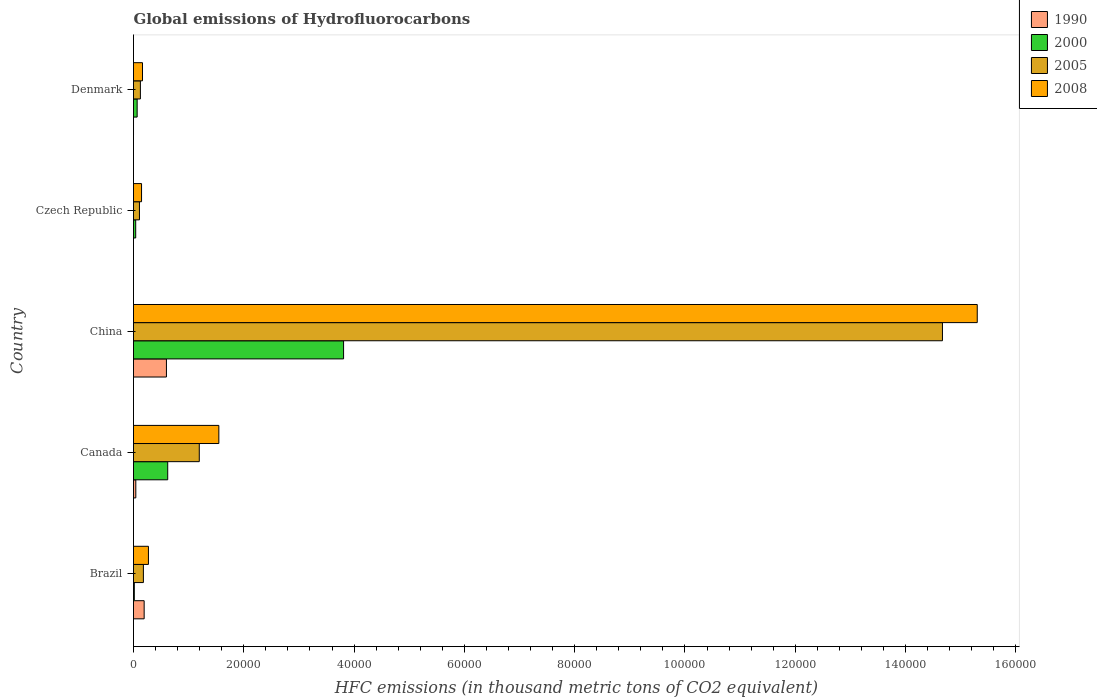How many groups of bars are there?
Provide a short and direct response. 5. How many bars are there on the 2nd tick from the top?
Provide a short and direct response. 4. In how many cases, is the number of bars for a given country not equal to the number of legend labels?
Keep it short and to the point. 0. What is the global emissions of Hydrofluorocarbons in 1990 in Canada?
Your response must be concise. 418.5. Across all countries, what is the maximum global emissions of Hydrofluorocarbons in 1990?
Your answer should be compact. 5970.1. Across all countries, what is the minimum global emissions of Hydrofluorocarbons in 2008?
Your response must be concise. 1459. In which country was the global emissions of Hydrofluorocarbons in 2008 maximum?
Provide a succinct answer. China. In which country was the global emissions of Hydrofluorocarbons in 2005 minimum?
Your answer should be compact. Czech Republic. What is the total global emissions of Hydrofluorocarbons in 2000 in the graph?
Ensure brevity in your answer.  4.55e+04. What is the difference between the global emissions of Hydrofluorocarbons in 2008 in Brazil and that in Denmark?
Ensure brevity in your answer.  1077.9. What is the difference between the global emissions of Hydrofluorocarbons in 1990 in Denmark and the global emissions of Hydrofluorocarbons in 2005 in Canada?
Provide a succinct answer. -1.19e+04. What is the average global emissions of Hydrofluorocarbons in 2008 per country?
Offer a very short reply. 3.49e+04. What is the difference between the global emissions of Hydrofluorocarbons in 2000 and global emissions of Hydrofluorocarbons in 2005 in Czech Republic?
Provide a short and direct response. -679.2. What is the ratio of the global emissions of Hydrofluorocarbons in 1990 in China to that in Denmark?
Ensure brevity in your answer.  1.99e+04. Is the difference between the global emissions of Hydrofluorocarbons in 2000 in Canada and China greater than the difference between the global emissions of Hydrofluorocarbons in 2005 in Canada and China?
Ensure brevity in your answer.  Yes. What is the difference between the highest and the second highest global emissions of Hydrofluorocarbons in 1990?
Give a very brief answer. 4039.4. What is the difference between the highest and the lowest global emissions of Hydrofluorocarbons in 2000?
Keep it short and to the point. 3.79e+04. Is the sum of the global emissions of Hydrofluorocarbons in 2005 in Brazil and Denmark greater than the maximum global emissions of Hydrofluorocarbons in 1990 across all countries?
Give a very brief answer. No. Is it the case that in every country, the sum of the global emissions of Hydrofluorocarbons in 2000 and global emissions of Hydrofluorocarbons in 2005 is greater than the sum of global emissions of Hydrofluorocarbons in 1990 and global emissions of Hydrofluorocarbons in 2008?
Offer a very short reply. No. What does the 2nd bar from the top in China represents?
Make the answer very short. 2005. What does the 2nd bar from the bottom in China represents?
Offer a terse response. 2000. Is it the case that in every country, the sum of the global emissions of Hydrofluorocarbons in 2008 and global emissions of Hydrofluorocarbons in 1990 is greater than the global emissions of Hydrofluorocarbons in 2005?
Your answer should be compact. Yes. Are all the bars in the graph horizontal?
Your answer should be compact. Yes. How many countries are there in the graph?
Offer a terse response. 5. What is the difference between two consecutive major ticks on the X-axis?
Your answer should be very brief. 2.00e+04. Does the graph contain any zero values?
Ensure brevity in your answer.  No. How are the legend labels stacked?
Your answer should be very brief. Vertical. What is the title of the graph?
Offer a terse response. Global emissions of Hydrofluorocarbons. What is the label or title of the X-axis?
Provide a short and direct response. HFC emissions (in thousand metric tons of CO2 equivalent). What is the HFC emissions (in thousand metric tons of CO2 equivalent) in 1990 in Brazil?
Keep it short and to the point. 1930.7. What is the HFC emissions (in thousand metric tons of CO2 equivalent) in 2000 in Brazil?
Your answer should be very brief. 147.4. What is the HFC emissions (in thousand metric tons of CO2 equivalent) of 2005 in Brazil?
Your response must be concise. 1793.4. What is the HFC emissions (in thousand metric tons of CO2 equivalent) of 2008 in Brazil?
Your answer should be compact. 2707.5. What is the HFC emissions (in thousand metric tons of CO2 equivalent) of 1990 in Canada?
Keep it short and to the point. 418.5. What is the HFC emissions (in thousand metric tons of CO2 equivalent) in 2000 in Canada?
Ensure brevity in your answer.  6202.8. What is the HFC emissions (in thousand metric tons of CO2 equivalent) in 2005 in Canada?
Make the answer very short. 1.19e+04. What is the HFC emissions (in thousand metric tons of CO2 equivalent) in 2008 in Canada?
Your answer should be very brief. 1.55e+04. What is the HFC emissions (in thousand metric tons of CO2 equivalent) in 1990 in China?
Provide a short and direct response. 5970.1. What is the HFC emissions (in thousand metric tons of CO2 equivalent) in 2000 in China?
Keep it short and to the point. 3.81e+04. What is the HFC emissions (in thousand metric tons of CO2 equivalent) of 2005 in China?
Offer a terse response. 1.47e+05. What is the HFC emissions (in thousand metric tons of CO2 equivalent) in 2008 in China?
Your response must be concise. 1.53e+05. What is the HFC emissions (in thousand metric tons of CO2 equivalent) in 2000 in Czech Republic?
Your answer should be very brief. 399.5. What is the HFC emissions (in thousand metric tons of CO2 equivalent) in 2005 in Czech Republic?
Provide a succinct answer. 1078.7. What is the HFC emissions (in thousand metric tons of CO2 equivalent) of 2008 in Czech Republic?
Provide a succinct answer. 1459. What is the HFC emissions (in thousand metric tons of CO2 equivalent) of 1990 in Denmark?
Offer a terse response. 0.3. What is the HFC emissions (in thousand metric tons of CO2 equivalent) of 2000 in Denmark?
Offer a very short reply. 662.2. What is the HFC emissions (in thousand metric tons of CO2 equivalent) of 2005 in Denmark?
Provide a succinct answer. 1249.5. What is the HFC emissions (in thousand metric tons of CO2 equivalent) of 2008 in Denmark?
Offer a very short reply. 1629.6. Across all countries, what is the maximum HFC emissions (in thousand metric tons of CO2 equivalent) in 1990?
Ensure brevity in your answer.  5970.1. Across all countries, what is the maximum HFC emissions (in thousand metric tons of CO2 equivalent) in 2000?
Your answer should be very brief. 3.81e+04. Across all countries, what is the maximum HFC emissions (in thousand metric tons of CO2 equivalent) in 2005?
Your answer should be very brief. 1.47e+05. Across all countries, what is the maximum HFC emissions (in thousand metric tons of CO2 equivalent) in 2008?
Give a very brief answer. 1.53e+05. Across all countries, what is the minimum HFC emissions (in thousand metric tons of CO2 equivalent) in 1990?
Make the answer very short. 0.1. Across all countries, what is the minimum HFC emissions (in thousand metric tons of CO2 equivalent) of 2000?
Give a very brief answer. 147.4. Across all countries, what is the minimum HFC emissions (in thousand metric tons of CO2 equivalent) in 2005?
Ensure brevity in your answer.  1078.7. Across all countries, what is the minimum HFC emissions (in thousand metric tons of CO2 equivalent) in 2008?
Give a very brief answer. 1459. What is the total HFC emissions (in thousand metric tons of CO2 equivalent) in 1990 in the graph?
Your response must be concise. 8319.7. What is the total HFC emissions (in thousand metric tons of CO2 equivalent) of 2000 in the graph?
Make the answer very short. 4.55e+04. What is the total HFC emissions (in thousand metric tons of CO2 equivalent) of 2005 in the graph?
Provide a short and direct response. 1.63e+05. What is the total HFC emissions (in thousand metric tons of CO2 equivalent) of 2008 in the graph?
Your answer should be compact. 1.74e+05. What is the difference between the HFC emissions (in thousand metric tons of CO2 equivalent) in 1990 in Brazil and that in Canada?
Your answer should be very brief. 1512.2. What is the difference between the HFC emissions (in thousand metric tons of CO2 equivalent) of 2000 in Brazil and that in Canada?
Make the answer very short. -6055.4. What is the difference between the HFC emissions (in thousand metric tons of CO2 equivalent) of 2005 in Brazil and that in Canada?
Give a very brief answer. -1.01e+04. What is the difference between the HFC emissions (in thousand metric tons of CO2 equivalent) in 2008 in Brazil and that in Canada?
Provide a short and direct response. -1.28e+04. What is the difference between the HFC emissions (in thousand metric tons of CO2 equivalent) of 1990 in Brazil and that in China?
Make the answer very short. -4039.4. What is the difference between the HFC emissions (in thousand metric tons of CO2 equivalent) of 2000 in Brazil and that in China?
Provide a short and direct response. -3.79e+04. What is the difference between the HFC emissions (in thousand metric tons of CO2 equivalent) of 2005 in Brazil and that in China?
Your response must be concise. -1.45e+05. What is the difference between the HFC emissions (in thousand metric tons of CO2 equivalent) in 2008 in Brazil and that in China?
Provide a short and direct response. -1.50e+05. What is the difference between the HFC emissions (in thousand metric tons of CO2 equivalent) in 1990 in Brazil and that in Czech Republic?
Provide a succinct answer. 1930.6. What is the difference between the HFC emissions (in thousand metric tons of CO2 equivalent) of 2000 in Brazil and that in Czech Republic?
Keep it short and to the point. -252.1. What is the difference between the HFC emissions (in thousand metric tons of CO2 equivalent) in 2005 in Brazil and that in Czech Republic?
Offer a terse response. 714.7. What is the difference between the HFC emissions (in thousand metric tons of CO2 equivalent) of 2008 in Brazil and that in Czech Republic?
Your answer should be very brief. 1248.5. What is the difference between the HFC emissions (in thousand metric tons of CO2 equivalent) of 1990 in Brazil and that in Denmark?
Make the answer very short. 1930.4. What is the difference between the HFC emissions (in thousand metric tons of CO2 equivalent) of 2000 in Brazil and that in Denmark?
Offer a very short reply. -514.8. What is the difference between the HFC emissions (in thousand metric tons of CO2 equivalent) in 2005 in Brazil and that in Denmark?
Give a very brief answer. 543.9. What is the difference between the HFC emissions (in thousand metric tons of CO2 equivalent) in 2008 in Brazil and that in Denmark?
Ensure brevity in your answer.  1077.9. What is the difference between the HFC emissions (in thousand metric tons of CO2 equivalent) in 1990 in Canada and that in China?
Your answer should be compact. -5551.6. What is the difference between the HFC emissions (in thousand metric tons of CO2 equivalent) in 2000 in Canada and that in China?
Your answer should be compact. -3.19e+04. What is the difference between the HFC emissions (in thousand metric tons of CO2 equivalent) in 2005 in Canada and that in China?
Keep it short and to the point. -1.35e+05. What is the difference between the HFC emissions (in thousand metric tons of CO2 equivalent) in 2008 in Canada and that in China?
Make the answer very short. -1.38e+05. What is the difference between the HFC emissions (in thousand metric tons of CO2 equivalent) in 1990 in Canada and that in Czech Republic?
Make the answer very short. 418.4. What is the difference between the HFC emissions (in thousand metric tons of CO2 equivalent) in 2000 in Canada and that in Czech Republic?
Your answer should be compact. 5803.3. What is the difference between the HFC emissions (in thousand metric tons of CO2 equivalent) in 2005 in Canada and that in Czech Republic?
Provide a short and direct response. 1.08e+04. What is the difference between the HFC emissions (in thousand metric tons of CO2 equivalent) in 2008 in Canada and that in Czech Republic?
Offer a very short reply. 1.40e+04. What is the difference between the HFC emissions (in thousand metric tons of CO2 equivalent) in 1990 in Canada and that in Denmark?
Provide a short and direct response. 418.2. What is the difference between the HFC emissions (in thousand metric tons of CO2 equivalent) in 2000 in Canada and that in Denmark?
Offer a very short reply. 5540.6. What is the difference between the HFC emissions (in thousand metric tons of CO2 equivalent) in 2005 in Canada and that in Denmark?
Ensure brevity in your answer.  1.07e+04. What is the difference between the HFC emissions (in thousand metric tons of CO2 equivalent) in 2008 in Canada and that in Denmark?
Give a very brief answer. 1.38e+04. What is the difference between the HFC emissions (in thousand metric tons of CO2 equivalent) of 1990 in China and that in Czech Republic?
Your response must be concise. 5970. What is the difference between the HFC emissions (in thousand metric tons of CO2 equivalent) of 2000 in China and that in Czech Republic?
Provide a succinct answer. 3.77e+04. What is the difference between the HFC emissions (in thousand metric tons of CO2 equivalent) in 2005 in China and that in Czech Republic?
Your answer should be very brief. 1.46e+05. What is the difference between the HFC emissions (in thousand metric tons of CO2 equivalent) of 2008 in China and that in Czech Republic?
Give a very brief answer. 1.52e+05. What is the difference between the HFC emissions (in thousand metric tons of CO2 equivalent) of 1990 in China and that in Denmark?
Ensure brevity in your answer.  5969.8. What is the difference between the HFC emissions (in thousand metric tons of CO2 equivalent) of 2000 in China and that in Denmark?
Ensure brevity in your answer.  3.74e+04. What is the difference between the HFC emissions (in thousand metric tons of CO2 equivalent) of 2005 in China and that in Denmark?
Offer a very short reply. 1.45e+05. What is the difference between the HFC emissions (in thousand metric tons of CO2 equivalent) of 2008 in China and that in Denmark?
Offer a very short reply. 1.51e+05. What is the difference between the HFC emissions (in thousand metric tons of CO2 equivalent) in 2000 in Czech Republic and that in Denmark?
Your answer should be compact. -262.7. What is the difference between the HFC emissions (in thousand metric tons of CO2 equivalent) of 2005 in Czech Republic and that in Denmark?
Provide a short and direct response. -170.8. What is the difference between the HFC emissions (in thousand metric tons of CO2 equivalent) of 2008 in Czech Republic and that in Denmark?
Give a very brief answer. -170.6. What is the difference between the HFC emissions (in thousand metric tons of CO2 equivalent) in 1990 in Brazil and the HFC emissions (in thousand metric tons of CO2 equivalent) in 2000 in Canada?
Your answer should be compact. -4272.1. What is the difference between the HFC emissions (in thousand metric tons of CO2 equivalent) in 1990 in Brazil and the HFC emissions (in thousand metric tons of CO2 equivalent) in 2005 in Canada?
Provide a succinct answer. -9997.7. What is the difference between the HFC emissions (in thousand metric tons of CO2 equivalent) in 1990 in Brazil and the HFC emissions (in thousand metric tons of CO2 equivalent) in 2008 in Canada?
Give a very brief answer. -1.35e+04. What is the difference between the HFC emissions (in thousand metric tons of CO2 equivalent) of 2000 in Brazil and the HFC emissions (in thousand metric tons of CO2 equivalent) of 2005 in Canada?
Provide a succinct answer. -1.18e+04. What is the difference between the HFC emissions (in thousand metric tons of CO2 equivalent) of 2000 in Brazil and the HFC emissions (in thousand metric tons of CO2 equivalent) of 2008 in Canada?
Make the answer very short. -1.53e+04. What is the difference between the HFC emissions (in thousand metric tons of CO2 equivalent) in 2005 in Brazil and the HFC emissions (in thousand metric tons of CO2 equivalent) in 2008 in Canada?
Your response must be concise. -1.37e+04. What is the difference between the HFC emissions (in thousand metric tons of CO2 equivalent) of 1990 in Brazil and the HFC emissions (in thousand metric tons of CO2 equivalent) of 2000 in China?
Ensure brevity in your answer.  -3.62e+04. What is the difference between the HFC emissions (in thousand metric tons of CO2 equivalent) of 1990 in Brazil and the HFC emissions (in thousand metric tons of CO2 equivalent) of 2005 in China?
Provide a short and direct response. -1.45e+05. What is the difference between the HFC emissions (in thousand metric tons of CO2 equivalent) in 1990 in Brazil and the HFC emissions (in thousand metric tons of CO2 equivalent) in 2008 in China?
Offer a very short reply. -1.51e+05. What is the difference between the HFC emissions (in thousand metric tons of CO2 equivalent) of 2000 in Brazil and the HFC emissions (in thousand metric tons of CO2 equivalent) of 2005 in China?
Ensure brevity in your answer.  -1.47e+05. What is the difference between the HFC emissions (in thousand metric tons of CO2 equivalent) in 2000 in Brazil and the HFC emissions (in thousand metric tons of CO2 equivalent) in 2008 in China?
Keep it short and to the point. -1.53e+05. What is the difference between the HFC emissions (in thousand metric tons of CO2 equivalent) of 2005 in Brazil and the HFC emissions (in thousand metric tons of CO2 equivalent) of 2008 in China?
Offer a terse response. -1.51e+05. What is the difference between the HFC emissions (in thousand metric tons of CO2 equivalent) in 1990 in Brazil and the HFC emissions (in thousand metric tons of CO2 equivalent) in 2000 in Czech Republic?
Provide a short and direct response. 1531.2. What is the difference between the HFC emissions (in thousand metric tons of CO2 equivalent) in 1990 in Brazil and the HFC emissions (in thousand metric tons of CO2 equivalent) in 2005 in Czech Republic?
Your answer should be very brief. 852. What is the difference between the HFC emissions (in thousand metric tons of CO2 equivalent) of 1990 in Brazil and the HFC emissions (in thousand metric tons of CO2 equivalent) of 2008 in Czech Republic?
Your response must be concise. 471.7. What is the difference between the HFC emissions (in thousand metric tons of CO2 equivalent) in 2000 in Brazil and the HFC emissions (in thousand metric tons of CO2 equivalent) in 2005 in Czech Republic?
Your response must be concise. -931.3. What is the difference between the HFC emissions (in thousand metric tons of CO2 equivalent) of 2000 in Brazil and the HFC emissions (in thousand metric tons of CO2 equivalent) of 2008 in Czech Republic?
Offer a terse response. -1311.6. What is the difference between the HFC emissions (in thousand metric tons of CO2 equivalent) in 2005 in Brazil and the HFC emissions (in thousand metric tons of CO2 equivalent) in 2008 in Czech Republic?
Ensure brevity in your answer.  334.4. What is the difference between the HFC emissions (in thousand metric tons of CO2 equivalent) in 1990 in Brazil and the HFC emissions (in thousand metric tons of CO2 equivalent) in 2000 in Denmark?
Provide a succinct answer. 1268.5. What is the difference between the HFC emissions (in thousand metric tons of CO2 equivalent) of 1990 in Brazil and the HFC emissions (in thousand metric tons of CO2 equivalent) of 2005 in Denmark?
Your answer should be very brief. 681.2. What is the difference between the HFC emissions (in thousand metric tons of CO2 equivalent) of 1990 in Brazil and the HFC emissions (in thousand metric tons of CO2 equivalent) of 2008 in Denmark?
Your answer should be very brief. 301.1. What is the difference between the HFC emissions (in thousand metric tons of CO2 equivalent) in 2000 in Brazil and the HFC emissions (in thousand metric tons of CO2 equivalent) in 2005 in Denmark?
Your response must be concise. -1102.1. What is the difference between the HFC emissions (in thousand metric tons of CO2 equivalent) in 2000 in Brazil and the HFC emissions (in thousand metric tons of CO2 equivalent) in 2008 in Denmark?
Offer a terse response. -1482.2. What is the difference between the HFC emissions (in thousand metric tons of CO2 equivalent) in 2005 in Brazil and the HFC emissions (in thousand metric tons of CO2 equivalent) in 2008 in Denmark?
Provide a succinct answer. 163.8. What is the difference between the HFC emissions (in thousand metric tons of CO2 equivalent) of 1990 in Canada and the HFC emissions (in thousand metric tons of CO2 equivalent) of 2000 in China?
Give a very brief answer. -3.77e+04. What is the difference between the HFC emissions (in thousand metric tons of CO2 equivalent) of 1990 in Canada and the HFC emissions (in thousand metric tons of CO2 equivalent) of 2005 in China?
Offer a very short reply. -1.46e+05. What is the difference between the HFC emissions (in thousand metric tons of CO2 equivalent) in 1990 in Canada and the HFC emissions (in thousand metric tons of CO2 equivalent) in 2008 in China?
Provide a succinct answer. -1.53e+05. What is the difference between the HFC emissions (in thousand metric tons of CO2 equivalent) in 2000 in Canada and the HFC emissions (in thousand metric tons of CO2 equivalent) in 2005 in China?
Offer a very short reply. -1.40e+05. What is the difference between the HFC emissions (in thousand metric tons of CO2 equivalent) in 2000 in Canada and the HFC emissions (in thousand metric tons of CO2 equivalent) in 2008 in China?
Your answer should be compact. -1.47e+05. What is the difference between the HFC emissions (in thousand metric tons of CO2 equivalent) of 2005 in Canada and the HFC emissions (in thousand metric tons of CO2 equivalent) of 2008 in China?
Your answer should be compact. -1.41e+05. What is the difference between the HFC emissions (in thousand metric tons of CO2 equivalent) in 1990 in Canada and the HFC emissions (in thousand metric tons of CO2 equivalent) in 2005 in Czech Republic?
Your answer should be compact. -660.2. What is the difference between the HFC emissions (in thousand metric tons of CO2 equivalent) of 1990 in Canada and the HFC emissions (in thousand metric tons of CO2 equivalent) of 2008 in Czech Republic?
Give a very brief answer. -1040.5. What is the difference between the HFC emissions (in thousand metric tons of CO2 equivalent) in 2000 in Canada and the HFC emissions (in thousand metric tons of CO2 equivalent) in 2005 in Czech Republic?
Ensure brevity in your answer.  5124.1. What is the difference between the HFC emissions (in thousand metric tons of CO2 equivalent) in 2000 in Canada and the HFC emissions (in thousand metric tons of CO2 equivalent) in 2008 in Czech Republic?
Your response must be concise. 4743.8. What is the difference between the HFC emissions (in thousand metric tons of CO2 equivalent) in 2005 in Canada and the HFC emissions (in thousand metric tons of CO2 equivalent) in 2008 in Czech Republic?
Your response must be concise. 1.05e+04. What is the difference between the HFC emissions (in thousand metric tons of CO2 equivalent) in 1990 in Canada and the HFC emissions (in thousand metric tons of CO2 equivalent) in 2000 in Denmark?
Your response must be concise. -243.7. What is the difference between the HFC emissions (in thousand metric tons of CO2 equivalent) of 1990 in Canada and the HFC emissions (in thousand metric tons of CO2 equivalent) of 2005 in Denmark?
Provide a short and direct response. -831. What is the difference between the HFC emissions (in thousand metric tons of CO2 equivalent) of 1990 in Canada and the HFC emissions (in thousand metric tons of CO2 equivalent) of 2008 in Denmark?
Keep it short and to the point. -1211.1. What is the difference between the HFC emissions (in thousand metric tons of CO2 equivalent) in 2000 in Canada and the HFC emissions (in thousand metric tons of CO2 equivalent) in 2005 in Denmark?
Your response must be concise. 4953.3. What is the difference between the HFC emissions (in thousand metric tons of CO2 equivalent) in 2000 in Canada and the HFC emissions (in thousand metric tons of CO2 equivalent) in 2008 in Denmark?
Your answer should be very brief. 4573.2. What is the difference between the HFC emissions (in thousand metric tons of CO2 equivalent) in 2005 in Canada and the HFC emissions (in thousand metric tons of CO2 equivalent) in 2008 in Denmark?
Provide a short and direct response. 1.03e+04. What is the difference between the HFC emissions (in thousand metric tons of CO2 equivalent) of 1990 in China and the HFC emissions (in thousand metric tons of CO2 equivalent) of 2000 in Czech Republic?
Offer a very short reply. 5570.6. What is the difference between the HFC emissions (in thousand metric tons of CO2 equivalent) of 1990 in China and the HFC emissions (in thousand metric tons of CO2 equivalent) of 2005 in Czech Republic?
Give a very brief answer. 4891.4. What is the difference between the HFC emissions (in thousand metric tons of CO2 equivalent) of 1990 in China and the HFC emissions (in thousand metric tons of CO2 equivalent) of 2008 in Czech Republic?
Give a very brief answer. 4511.1. What is the difference between the HFC emissions (in thousand metric tons of CO2 equivalent) of 2000 in China and the HFC emissions (in thousand metric tons of CO2 equivalent) of 2005 in Czech Republic?
Offer a very short reply. 3.70e+04. What is the difference between the HFC emissions (in thousand metric tons of CO2 equivalent) of 2000 in China and the HFC emissions (in thousand metric tons of CO2 equivalent) of 2008 in Czech Republic?
Give a very brief answer. 3.66e+04. What is the difference between the HFC emissions (in thousand metric tons of CO2 equivalent) of 2005 in China and the HFC emissions (in thousand metric tons of CO2 equivalent) of 2008 in Czech Republic?
Give a very brief answer. 1.45e+05. What is the difference between the HFC emissions (in thousand metric tons of CO2 equivalent) of 1990 in China and the HFC emissions (in thousand metric tons of CO2 equivalent) of 2000 in Denmark?
Give a very brief answer. 5307.9. What is the difference between the HFC emissions (in thousand metric tons of CO2 equivalent) in 1990 in China and the HFC emissions (in thousand metric tons of CO2 equivalent) in 2005 in Denmark?
Your response must be concise. 4720.6. What is the difference between the HFC emissions (in thousand metric tons of CO2 equivalent) of 1990 in China and the HFC emissions (in thousand metric tons of CO2 equivalent) of 2008 in Denmark?
Your answer should be very brief. 4340.5. What is the difference between the HFC emissions (in thousand metric tons of CO2 equivalent) of 2000 in China and the HFC emissions (in thousand metric tons of CO2 equivalent) of 2005 in Denmark?
Offer a very short reply. 3.68e+04. What is the difference between the HFC emissions (in thousand metric tons of CO2 equivalent) of 2000 in China and the HFC emissions (in thousand metric tons of CO2 equivalent) of 2008 in Denmark?
Offer a very short reply. 3.65e+04. What is the difference between the HFC emissions (in thousand metric tons of CO2 equivalent) in 2005 in China and the HFC emissions (in thousand metric tons of CO2 equivalent) in 2008 in Denmark?
Your answer should be compact. 1.45e+05. What is the difference between the HFC emissions (in thousand metric tons of CO2 equivalent) in 1990 in Czech Republic and the HFC emissions (in thousand metric tons of CO2 equivalent) in 2000 in Denmark?
Your answer should be compact. -662.1. What is the difference between the HFC emissions (in thousand metric tons of CO2 equivalent) in 1990 in Czech Republic and the HFC emissions (in thousand metric tons of CO2 equivalent) in 2005 in Denmark?
Keep it short and to the point. -1249.4. What is the difference between the HFC emissions (in thousand metric tons of CO2 equivalent) in 1990 in Czech Republic and the HFC emissions (in thousand metric tons of CO2 equivalent) in 2008 in Denmark?
Your answer should be compact. -1629.5. What is the difference between the HFC emissions (in thousand metric tons of CO2 equivalent) in 2000 in Czech Republic and the HFC emissions (in thousand metric tons of CO2 equivalent) in 2005 in Denmark?
Make the answer very short. -850. What is the difference between the HFC emissions (in thousand metric tons of CO2 equivalent) in 2000 in Czech Republic and the HFC emissions (in thousand metric tons of CO2 equivalent) in 2008 in Denmark?
Provide a short and direct response. -1230.1. What is the difference between the HFC emissions (in thousand metric tons of CO2 equivalent) in 2005 in Czech Republic and the HFC emissions (in thousand metric tons of CO2 equivalent) in 2008 in Denmark?
Keep it short and to the point. -550.9. What is the average HFC emissions (in thousand metric tons of CO2 equivalent) of 1990 per country?
Keep it short and to the point. 1663.94. What is the average HFC emissions (in thousand metric tons of CO2 equivalent) in 2000 per country?
Keep it short and to the point. 9101.18. What is the average HFC emissions (in thousand metric tons of CO2 equivalent) of 2005 per country?
Your response must be concise. 3.25e+04. What is the average HFC emissions (in thousand metric tons of CO2 equivalent) in 2008 per country?
Keep it short and to the point. 3.49e+04. What is the difference between the HFC emissions (in thousand metric tons of CO2 equivalent) in 1990 and HFC emissions (in thousand metric tons of CO2 equivalent) in 2000 in Brazil?
Your response must be concise. 1783.3. What is the difference between the HFC emissions (in thousand metric tons of CO2 equivalent) in 1990 and HFC emissions (in thousand metric tons of CO2 equivalent) in 2005 in Brazil?
Give a very brief answer. 137.3. What is the difference between the HFC emissions (in thousand metric tons of CO2 equivalent) of 1990 and HFC emissions (in thousand metric tons of CO2 equivalent) of 2008 in Brazil?
Your response must be concise. -776.8. What is the difference between the HFC emissions (in thousand metric tons of CO2 equivalent) in 2000 and HFC emissions (in thousand metric tons of CO2 equivalent) in 2005 in Brazil?
Provide a succinct answer. -1646. What is the difference between the HFC emissions (in thousand metric tons of CO2 equivalent) in 2000 and HFC emissions (in thousand metric tons of CO2 equivalent) in 2008 in Brazil?
Your answer should be compact. -2560.1. What is the difference between the HFC emissions (in thousand metric tons of CO2 equivalent) of 2005 and HFC emissions (in thousand metric tons of CO2 equivalent) of 2008 in Brazil?
Your answer should be very brief. -914.1. What is the difference between the HFC emissions (in thousand metric tons of CO2 equivalent) in 1990 and HFC emissions (in thousand metric tons of CO2 equivalent) in 2000 in Canada?
Your answer should be very brief. -5784.3. What is the difference between the HFC emissions (in thousand metric tons of CO2 equivalent) of 1990 and HFC emissions (in thousand metric tons of CO2 equivalent) of 2005 in Canada?
Your answer should be very brief. -1.15e+04. What is the difference between the HFC emissions (in thousand metric tons of CO2 equivalent) of 1990 and HFC emissions (in thousand metric tons of CO2 equivalent) of 2008 in Canada?
Offer a very short reply. -1.51e+04. What is the difference between the HFC emissions (in thousand metric tons of CO2 equivalent) of 2000 and HFC emissions (in thousand metric tons of CO2 equivalent) of 2005 in Canada?
Ensure brevity in your answer.  -5725.6. What is the difference between the HFC emissions (in thousand metric tons of CO2 equivalent) in 2000 and HFC emissions (in thousand metric tons of CO2 equivalent) in 2008 in Canada?
Provide a short and direct response. -9272. What is the difference between the HFC emissions (in thousand metric tons of CO2 equivalent) in 2005 and HFC emissions (in thousand metric tons of CO2 equivalent) in 2008 in Canada?
Give a very brief answer. -3546.4. What is the difference between the HFC emissions (in thousand metric tons of CO2 equivalent) in 1990 and HFC emissions (in thousand metric tons of CO2 equivalent) in 2000 in China?
Provide a succinct answer. -3.21e+04. What is the difference between the HFC emissions (in thousand metric tons of CO2 equivalent) in 1990 and HFC emissions (in thousand metric tons of CO2 equivalent) in 2005 in China?
Your answer should be very brief. -1.41e+05. What is the difference between the HFC emissions (in thousand metric tons of CO2 equivalent) in 1990 and HFC emissions (in thousand metric tons of CO2 equivalent) in 2008 in China?
Offer a very short reply. -1.47e+05. What is the difference between the HFC emissions (in thousand metric tons of CO2 equivalent) in 2000 and HFC emissions (in thousand metric tons of CO2 equivalent) in 2005 in China?
Offer a very short reply. -1.09e+05. What is the difference between the HFC emissions (in thousand metric tons of CO2 equivalent) of 2000 and HFC emissions (in thousand metric tons of CO2 equivalent) of 2008 in China?
Offer a terse response. -1.15e+05. What is the difference between the HFC emissions (in thousand metric tons of CO2 equivalent) in 2005 and HFC emissions (in thousand metric tons of CO2 equivalent) in 2008 in China?
Ensure brevity in your answer.  -6309. What is the difference between the HFC emissions (in thousand metric tons of CO2 equivalent) of 1990 and HFC emissions (in thousand metric tons of CO2 equivalent) of 2000 in Czech Republic?
Your response must be concise. -399.4. What is the difference between the HFC emissions (in thousand metric tons of CO2 equivalent) in 1990 and HFC emissions (in thousand metric tons of CO2 equivalent) in 2005 in Czech Republic?
Your answer should be very brief. -1078.6. What is the difference between the HFC emissions (in thousand metric tons of CO2 equivalent) in 1990 and HFC emissions (in thousand metric tons of CO2 equivalent) in 2008 in Czech Republic?
Your response must be concise. -1458.9. What is the difference between the HFC emissions (in thousand metric tons of CO2 equivalent) in 2000 and HFC emissions (in thousand metric tons of CO2 equivalent) in 2005 in Czech Republic?
Make the answer very short. -679.2. What is the difference between the HFC emissions (in thousand metric tons of CO2 equivalent) of 2000 and HFC emissions (in thousand metric tons of CO2 equivalent) of 2008 in Czech Republic?
Ensure brevity in your answer.  -1059.5. What is the difference between the HFC emissions (in thousand metric tons of CO2 equivalent) of 2005 and HFC emissions (in thousand metric tons of CO2 equivalent) of 2008 in Czech Republic?
Your response must be concise. -380.3. What is the difference between the HFC emissions (in thousand metric tons of CO2 equivalent) in 1990 and HFC emissions (in thousand metric tons of CO2 equivalent) in 2000 in Denmark?
Keep it short and to the point. -661.9. What is the difference between the HFC emissions (in thousand metric tons of CO2 equivalent) in 1990 and HFC emissions (in thousand metric tons of CO2 equivalent) in 2005 in Denmark?
Offer a terse response. -1249.2. What is the difference between the HFC emissions (in thousand metric tons of CO2 equivalent) in 1990 and HFC emissions (in thousand metric tons of CO2 equivalent) in 2008 in Denmark?
Your answer should be compact. -1629.3. What is the difference between the HFC emissions (in thousand metric tons of CO2 equivalent) of 2000 and HFC emissions (in thousand metric tons of CO2 equivalent) of 2005 in Denmark?
Offer a very short reply. -587.3. What is the difference between the HFC emissions (in thousand metric tons of CO2 equivalent) of 2000 and HFC emissions (in thousand metric tons of CO2 equivalent) of 2008 in Denmark?
Give a very brief answer. -967.4. What is the difference between the HFC emissions (in thousand metric tons of CO2 equivalent) in 2005 and HFC emissions (in thousand metric tons of CO2 equivalent) in 2008 in Denmark?
Offer a very short reply. -380.1. What is the ratio of the HFC emissions (in thousand metric tons of CO2 equivalent) of 1990 in Brazil to that in Canada?
Ensure brevity in your answer.  4.61. What is the ratio of the HFC emissions (in thousand metric tons of CO2 equivalent) of 2000 in Brazil to that in Canada?
Provide a short and direct response. 0.02. What is the ratio of the HFC emissions (in thousand metric tons of CO2 equivalent) in 2005 in Brazil to that in Canada?
Keep it short and to the point. 0.15. What is the ratio of the HFC emissions (in thousand metric tons of CO2 equivalent) in 2008 in Brazil to that in Canada?
Provide a short and direct response. 0.17. What is the ratio of the HFC emissions (in thousand metric tons of CO2 equivalent) in 1990 in Brazil to that in China?
Offer a terse response. 0.32. What is the ratio of the HFC emissions (in thousand metric tons of CO2 equivalent) in 2000 in Brazil to that in China?
Offer a very short reply. 0. What is the ratio of the HFC emissions (in thousand metric tons of CO2 equivalent) in 2005 in Brazil to that in China?
Offer a terse response. 0.01. What is the ratio of the HFC emissions (in thousand metric tons of CO2 equivalent) in 2008 in Brazil to that in China?
Give a very brief answer. 0.02. What is the ratio of the HFC emissions (in thousand metric tons of CO2 equivalent) of 1990 in Brazil to that in Czech Republic?
Offer a terse response. 1.93e+04. What is the ratio of the HFC emissions (in thousand metric tons of CO2 equivalent) in 2000 in Brazil to that in Czech Republic?
Provide a short and direct response. 0.37. What is the ratio of the HFC emissions (in thousand metric tons of CO2 equivalent) in 2005 in Brazil to that in Czech Republic?
Ensure brevity in your answer.  1.66. What is the ratio of the HFC emissions (in thousand metric tons of CO2 equivalent) of 2008 in Brazil to that in Czech Republic?
Provide a succinct answer. 1.86. What is the ratio of the HFC emissions (in thousand metric tons of CO2 equivalent) in 1990 in Brazil to that in Denmark?
Make the answer very short. 6435.67. What is the ratio of the HFC emissions (in thousand metric tons of CO2 equivalent) in 2000 in Brazil to that in Denmark?
Your answer should be compact. 0.22. What is the ratio of the HFC emissions (in thousand metric tons of CO2 equivalent) of 2005 in Brazil to that in Denmark?
Offer a terse response. 1.44. What is the ratio of the HFC emissions (in thousand metric tons of CO2 equivalent) of 2008 in Brazil to that in Denmark?
Ensure brevity in your answer.  1.66. What is the ratio of the HFC emissions (in thousand metric tons of CO2 equivalent) of 1990 in Canada to that in China?
Offer a terse response. 0.07. What is the ratio of the HFC emissions (in thousand metric tons of CO2 equivalent) in 2000 in Canada to that in China?
Offer a terse response. 0.16. What is the ratio of the HFC emissions (in thousand metric tons of CO2 equivalent) of 2005 in Canada to that in China?
Offer a very short reply. 0.08. What is the ratio of the HFC emissions (in thousand metric tons of CO2 equivalent) in 2008 in Canada to that in China?
Offer a very short reply. 0.1. What is the ratio of the HFC emissions (in thousand metric tons of CO2 equivalent) in 1990 in Canada to that in Czech Republic?
Provide a succinct answer. 4185. What is the ratio of the HFC emissions (in thousand metric tons of CO2 equivalent) in 2000 in Canada to that in Czech Republic?
Your response must be concise. 15.53. What is the ratio of the HFC emissions (in thousand metric tons of CO2 equivalent) of 2005 in Canada to that in Czech Republic?
Offer a terse response. 11.06. What is the ratio of the HFC emissions (in thousand metric tons of CO2 equivalent) in 2008 in Canada to that in Czech Republic?
Your answer should be very brief. 10.61. What is the ratio of the HFC emissions (in thousand metric tons of CO2 equivalent) of 1990 in Canada to that in Denmark?
Give a very brief answer. 1395. What is the ratio of the HFC emissions (in thousand metric tons of CO2 equivalent) in 2000 in Canada to that in Denmark?
Offer a terse response. 9.37. What is the ratio of the HFC emissions (in thousand metric tons of CO2 equivalent) in 2005 in Canada to that in Denmark?
Make the answer very short. 9.55. What is the ratio of the HFC emissions (in thousand metric tons of CO2 equivalent) of 2008 in Canada to that in Denmark?
Offer a terse response. 9.5. What is the ratio of the HFC emissions (in thousand metric tons of CO2 equivalent) of 1990 in China to that in Czech Republic?
Your answer should be very brief. 5.97e+04. What is the ratio of the HFC emissions (in thousand metric tons of CO2 equivalent) in 2000 in China to that in Czech Republic?
Make the answer very short. 95.35. What is the ratio of the HFC emissions (in thousand metric tons of CO2 equivalent) in 2005 in China to that in Czech Republic?
Make the answer very short. 135.99. What is the ratio of the HFC emissions (in thousand metric tons of CO2 equivalent) of 2008 in China to that in Czech Republic?
Offer a very short reply. 104.87. What is the ratio of the HFC emissions (in thousand metric tons of CO2 equivalent) of 1990 in China to that in Denmark?
Give a very brief answer. 1.99e+04. What is the ratio of the HFC emissions (in thousand metric tons of CO2 equivalent) in 2000 in China to that in Denmark?
Your answer should be very brief. 57.53. What is the ratio of the HFC emissions (in thousand metric tons of CO2 equivalent) of 2005 in China to that in Denmark?
Your answer should be compact. 117.4. What is the ratio of the HFC emissions (in thousand metric tons of CO2 equivalent) of 2008 in China to that in Denmark?
Your response must be concise. 93.89. What is the ratio of the HFC emissions (in thousand metric tons of CO2 equivalent) of 2000 in Czech Republic to that in Denmark?
Offer a very short reply. 0.6. What is the ratio of the HFC emissions (in thousand metric tons of CO2 equivalent) of 2005 in Czech Republic to that in Denmark?
Make the answer very short. 0.86. What is the ratio of the HFC emissions (in thousand metric tons of CO2 equivalent) of 2008 in Czech Republic to that in Denmark?
Keep it short and to the point. 0.9. What is the difference between the highest and the second highest HFC emissions (in thousand metric tons of CO2 equivalent) in 1990?
Make the answer very short. 4039.4. What is the difference between the highest and the second highest HFC emissions (in thousand metric tons of CO2 equivalent) in 2000?
Provide a succinct answer. 3.19e+04. What is the difference between the highest and the second highest HFC emissions (in thousand metric tons of CO2 equivalent) of 2005?
Your answer should be compact. 1.35e+05. What is the difference between the highest and the second highest HFC emissions (in thousand metric tons of CO2 equivalent) of 2008?
Give a very brief answer. 1.38e+05. What is the difference between the highest and the lowest HFC emissions (in thousand metric tons of CO2 equivalent) of 1990?
Ensure brevity in your answer.  5970. What is the difference between the highest and the lowest HFC emissions (in thousand metric tons of CO2 equivalent) in 2000?
Your answer should be compact. 3.79e+04. What is the difference between the highest and the lowest HFC emissions (in thousand metric tons of CO2 equivalent) of 2005?
Your response must be concise. 1.46e+05. What is the difference between the highest and the lowest HFC emissions (in thousand metric tons of CO2 equivalent) in 2008?
Offer a very short reply. 1.52e+05. 